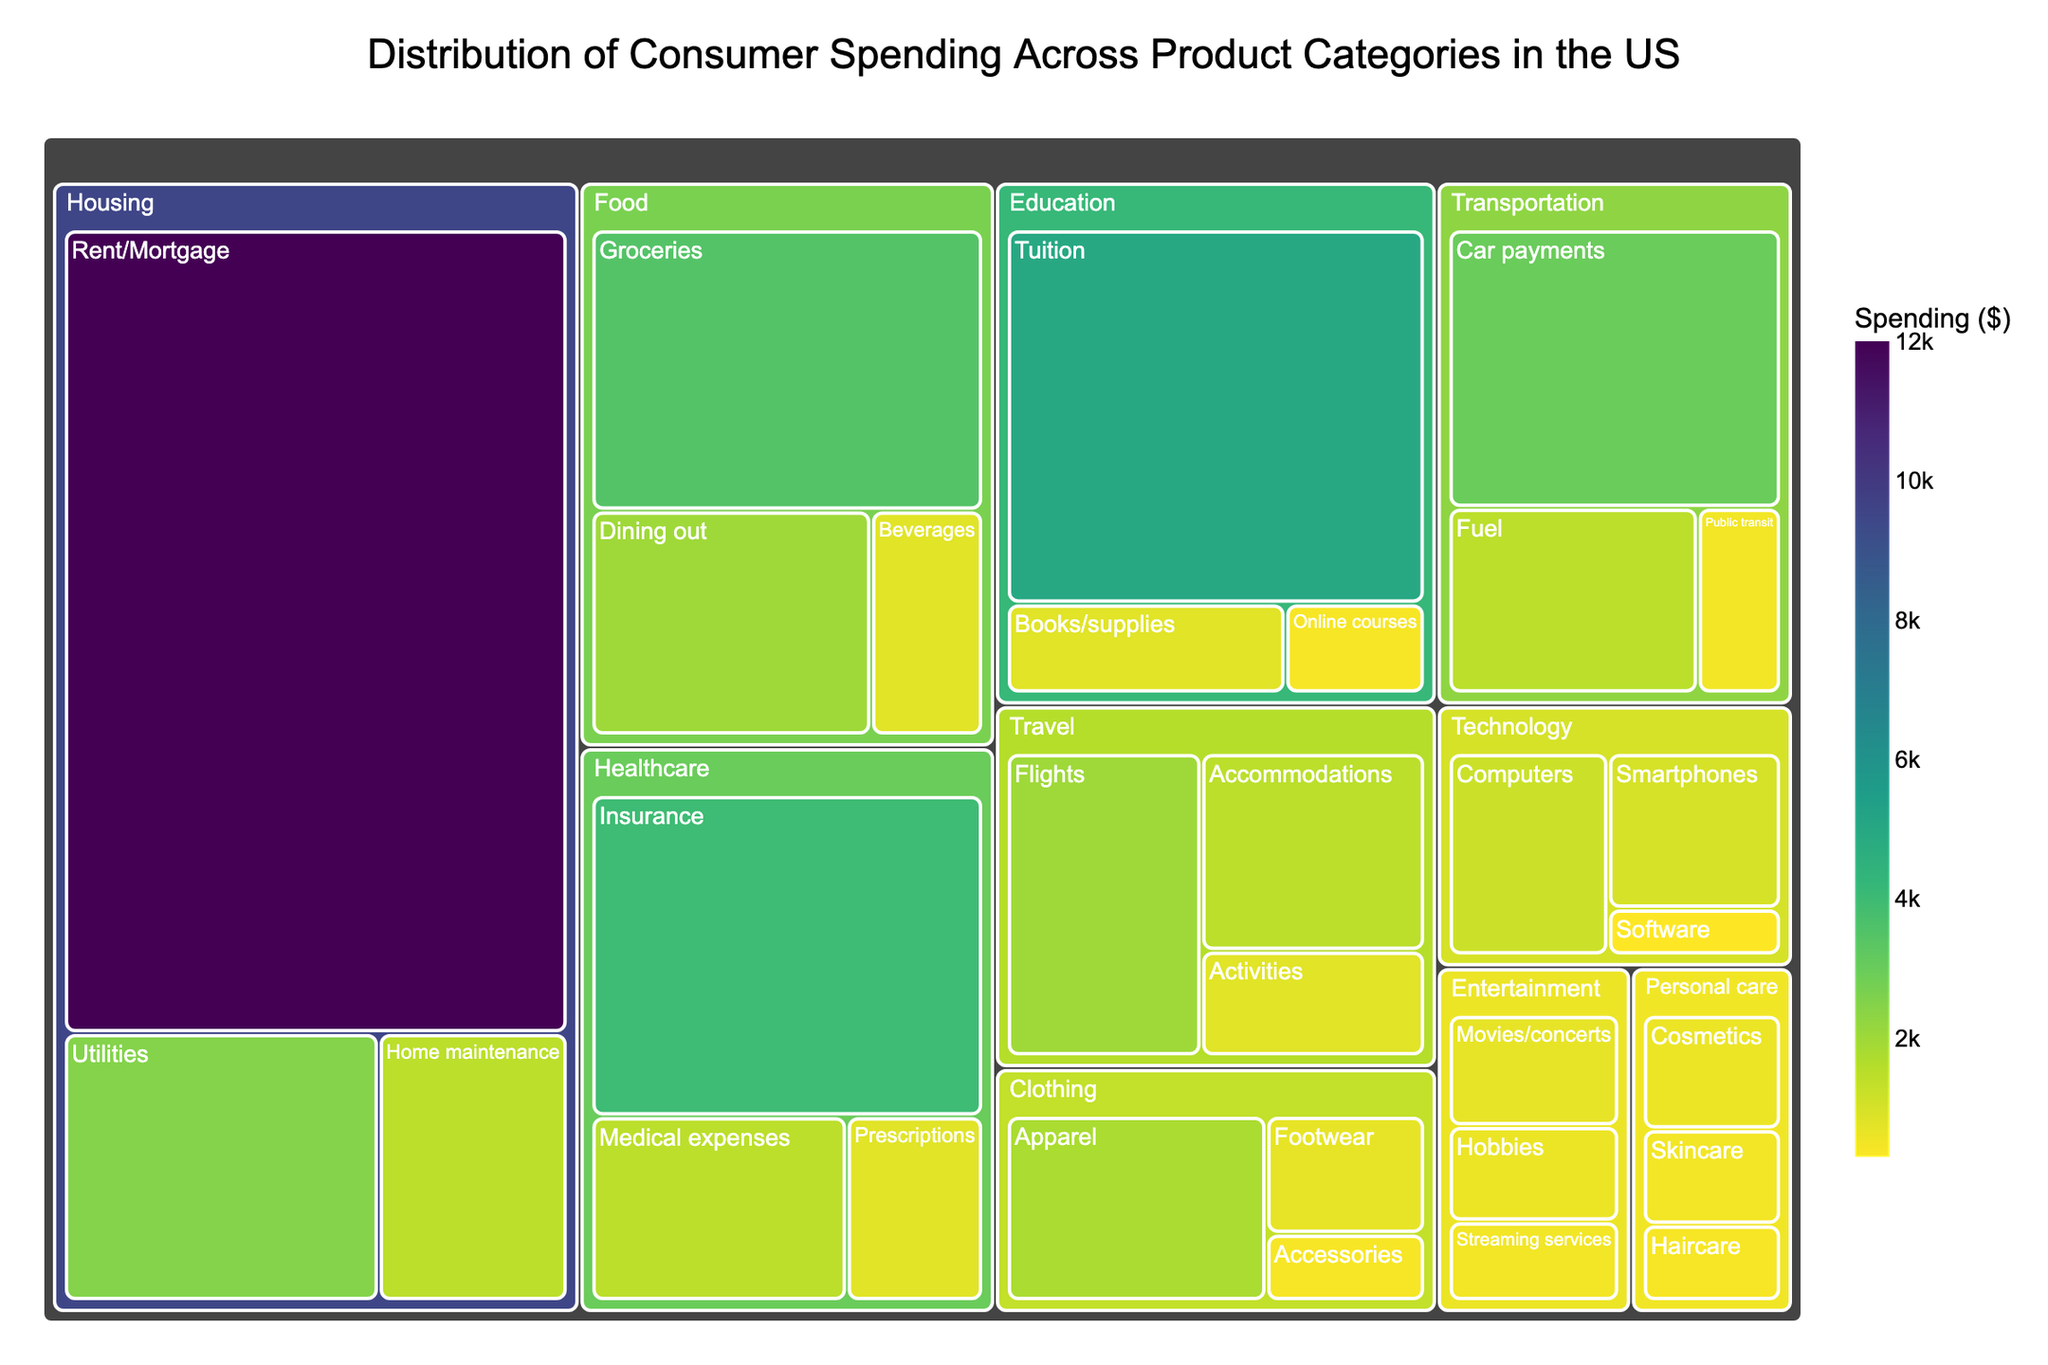What is the title of the treemap? The title of the treemap is displayed at the top of the figure. The title clearly states what the visual represents.
Answer: Distribution of Consumer Spending Across Product Categories in the US Which product category has the highest consumer spending? By examining the size of the rectangles, we can identify the largest one. Housing appears to have the largest area.
Answer: Housing What is the combined spending on Education and Healthcare? To find the combined spending, we add the values of Education ($6200) and Healthcare ($6300). Summing these values, we get $6200 + $6300.
Answer: $12,500 Which subcategory has the largest spending and what is its value? By comparing all subcategory rectangles, we can see that Rent/Mortgage under the Housing category has the largest area. The value for Rent/Mortgage is $12,000.
Answer: Rent/Mortgage, $12,000 How does spending on Dining out compare to spending on Groceries? We look at the sizes of the rectangles for Dining out and Groceries under the Food category. Groceries ($3500) has a larger area compared to Dining out ($2000). Therefore, spending on Groceries is higher.
Answer: Groceries has higher spending What is the total spending on all subcategories under Personal care? Personal Care has three subcategories: Cosmetics ($600), Haircare ($400), and Skincare ($500). Adding these values together: $600 + $400 + $500, we get $1500.
Answer: $1500 Between Transportation and Entertainment categories, which one has a smaller overall spending and by how much? Comparing the total values: Transportation ($5000) and Entertainment ($1800). The difference is calculated as $5000 - $1800, we get $3200.
Answer: Entertainment by $3200 What is the smallest subcategory in terms of spending and what is its value? The smallest subcategory rectangle would be the smallest visually. Software under Technology category has the smallest spending. Its value is $300.
Answer: Software, $300 What is the average spending on Travel subcategories? Travel has three subcategories: Flights ($2000), Accommodations ($1500), and Activities ($800). Summing these, $2000 + $1500 + $800 = $4300. To find the average, divide by 3: $4300 / 3.
Answer: $1433.33 